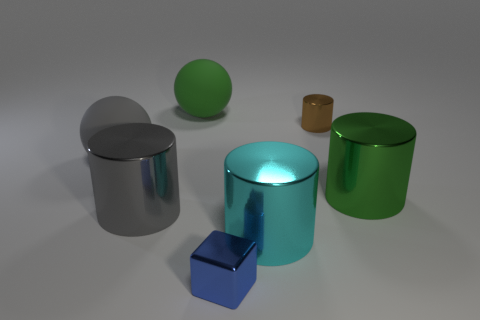Subtract all big cyan cylinders. How many cylinders are left? 3 Subtract all gray balls. How many balls are left? 1 Add 2 big matte cylinders. How many objects exist? 9 Subtract all cylinders. How many objects are left? 3 Subtract 1 spheres. How many spheres are left? 1 Subtract all red cylinders. How many brown blocks are left? 0 Subtract all purple balls. Subtract all green blocks. How many balls are left? 2 Subtract all large cylinders. Subtract all green rubber things. How many objects are left? 3 Add 2 big metal cylinders. How many big metal cylinders are left? 5 Add 4 small brown cylinders. How many small brown cylinders exist? 5 